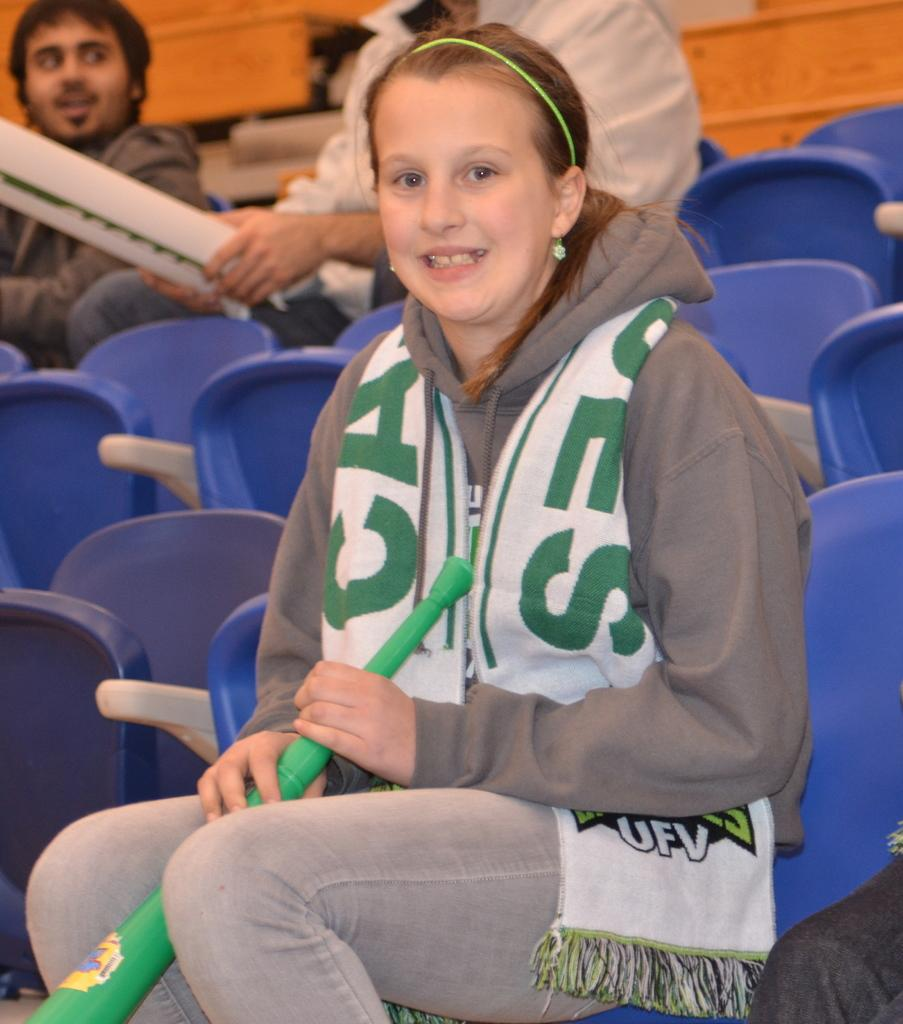<image>
Offer a succinct explanation of the picture presented. A fan of a sports team sits in the stands, her scarf reads UFV. 